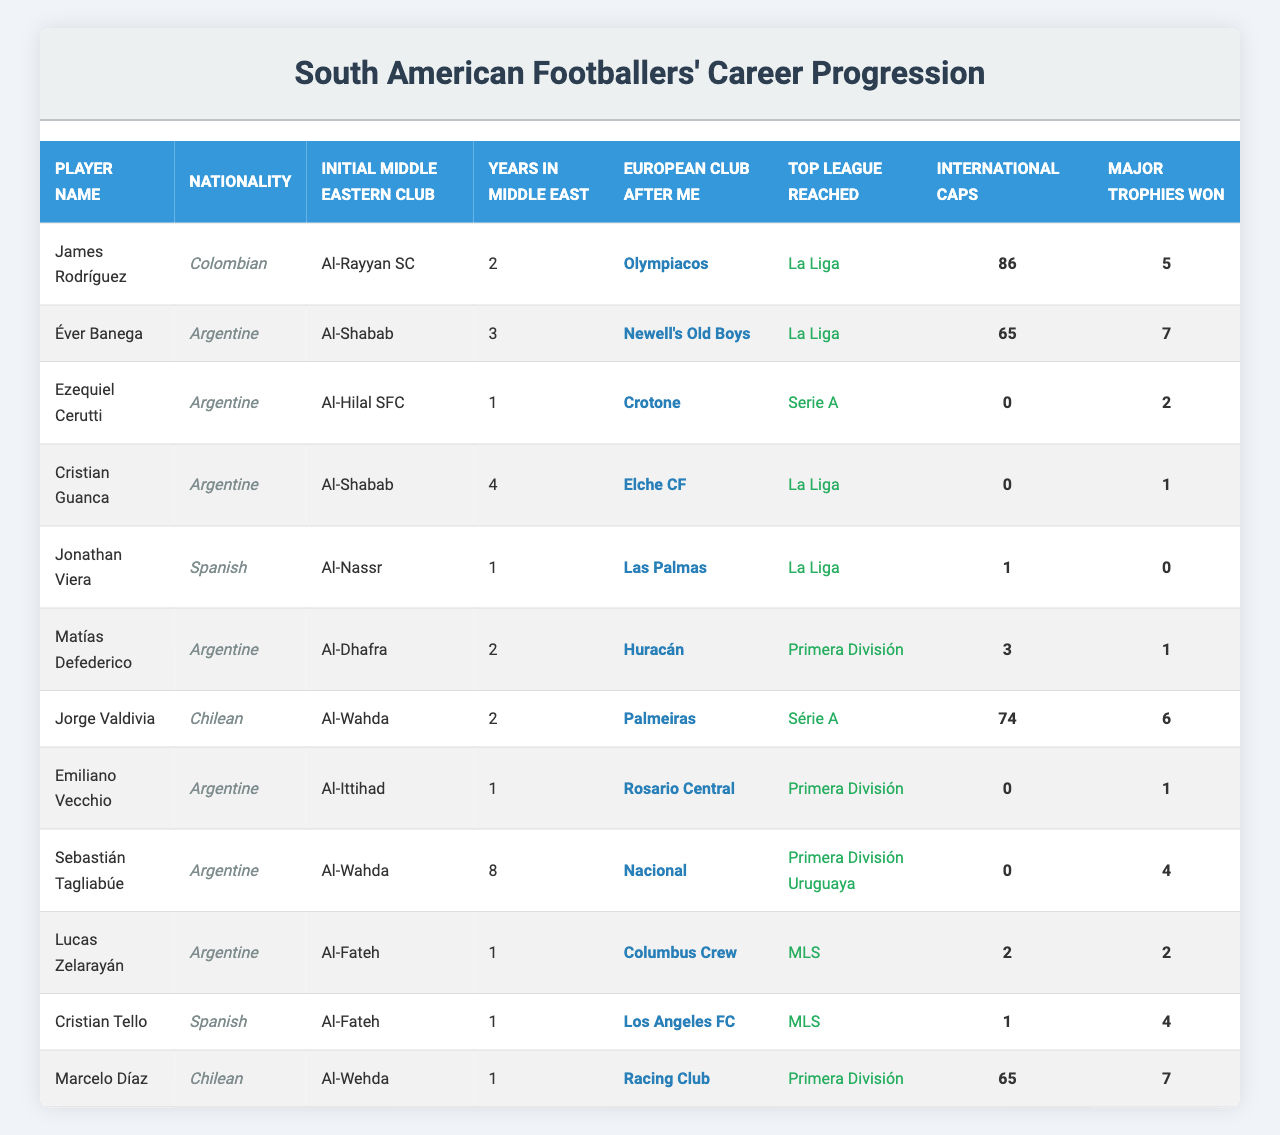What is the nationality of James Rodríguez? According to the table, James Rodríguez is listed under the Nationality column as Colombian.
Answer: Colombian Which player spent the most years in the Middle East? By scanning the Years in Middle East column, Sebastián Tagliabúe has the highest value of 8 years.
Answer: Sebastián Tagliabúe How many international caps did Ezequiel Cerutti earn? The table shows that Ezequiel Cerutti has 0 international caps listed under the International Caps column.
Answer: 0 Which player won the most major trophies and how many? The Major Trophies Won column shows that Éver Banega won 7 major trophies, which is the highest among the players listed.
Answer: Éver Banega, 7 Did any player have international caps without winning any major trophies? By examining the table, Emiliano Vecchio has 0 international caps and 1 major trophy, which suggests he doesn't qualify. However, Cristian Guanca has 0 caps and 1 trophy, confirming the condition is satisfied.
Answer: Yes Calculate the average number of international caps among the listed players. First, sum the international caps: 86 + 65 + 0 + 0 + 1 + 3 + 74 + 0 + 0 + 2 + 1 + 65 = 232. There are 12 players, so the average is 232 / 12 = 19.33.
Answer: 19.33 Which European club did Jonathan Viera join after leaving the Middle East? The table indicates that Jonathan Viera moved to Las Palmas after his time at Al-Nassr.
Answer: Las Palmas List the top league reached by Emiliano Vecchio. According to the table, Emiliano Vecchio reached the Primera División after leaving Al-Ittihad.
Answer: Primera División Who are the two players with the same initial Middle Eastern club, Al-Shabab? Scanning the Initial Middle Eastern Club column, both Éver Banega and Cristian Guanca are listed under Al-Shabab.
Answer: Éver Banega and Cristian Guanca What is the total number of major trophies won by all players in the table? By adding the Major Trophies Won for each player: 5 + 7 + 2 + 1 + 0 + 1 + 6 + 1 + 4 + 2 + 4 + 7 = 40.
Answer: 40 